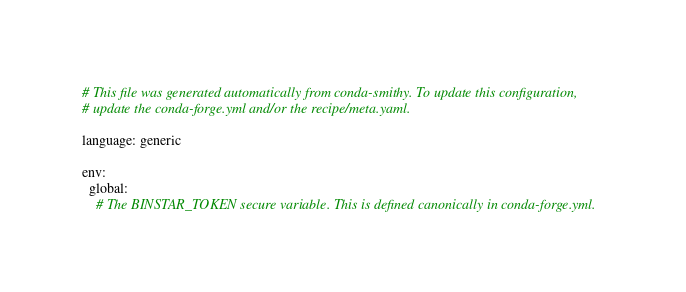Convert code to text. <code><loc_0><loc_0><loc_500><loc_500><_YAML_># This file was generated automatically from conda-smithy. To update this configuration,
# update the conda-forge.yml and/or the recipe/meta.yaml.

language: generic

env:
  global:
    # The BINSTAR_TOKEN secure variable. This is defined canonically in conda-forge.yml.</code> 